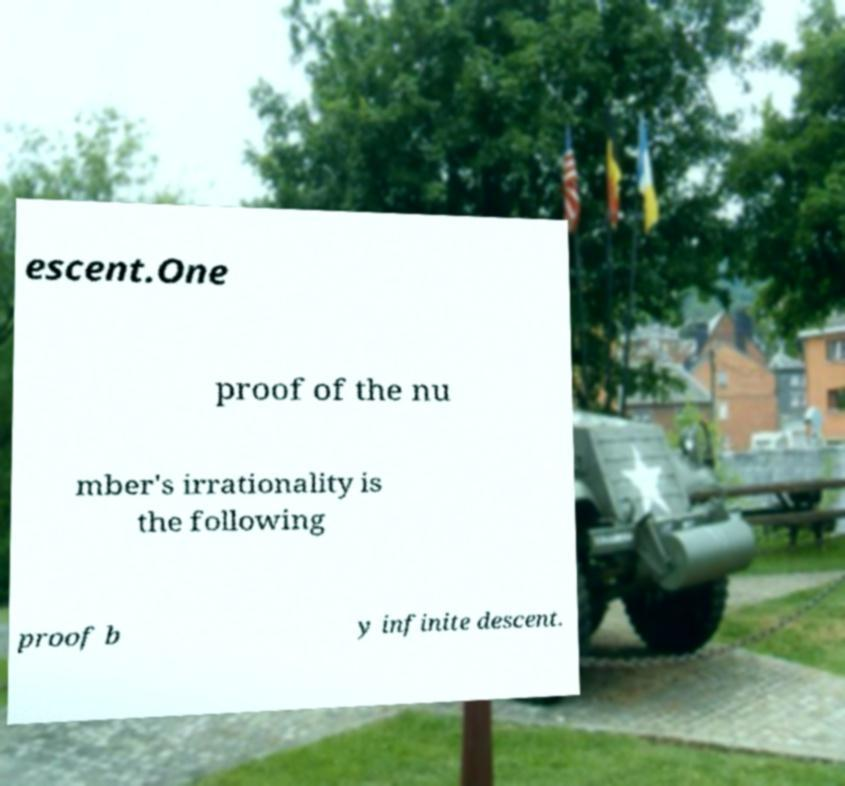For documentation purposes, I need the text within this image transcribed. Could you provide that? escent.One proof of the nu mber's irrationality is the following proof b y infinite descent. 